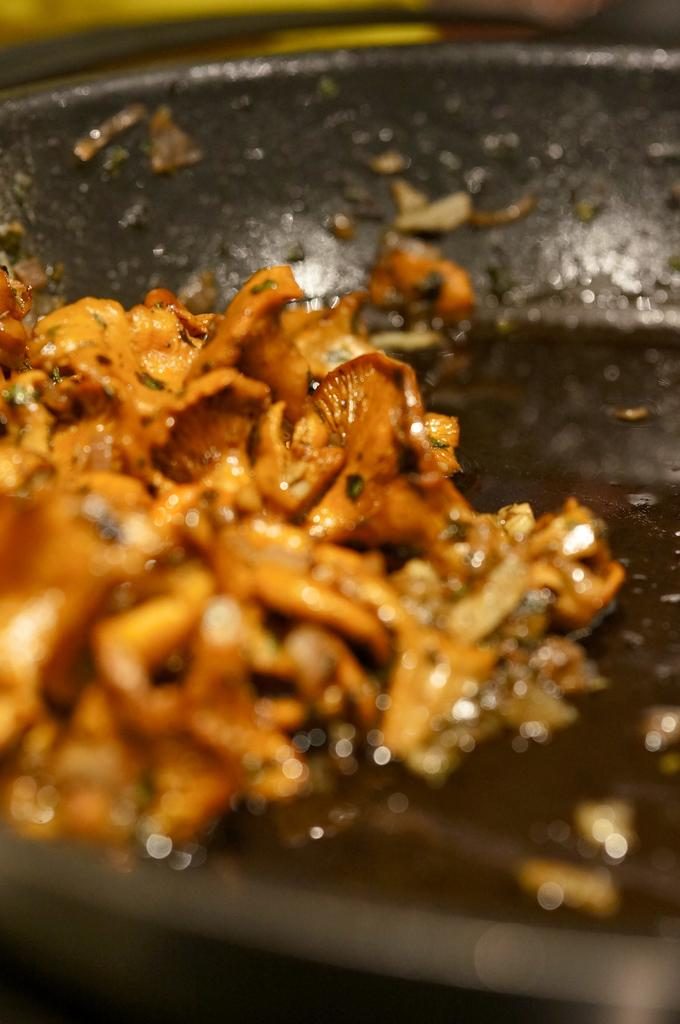What is the main subject of the image? There is a food item in the image. What can be observed about the pan in which the food item is placed? The pan is black in color. What type of drum can be seen playing in the background of the image? There is no drum present in the image; it only features a food item in a black pan. 